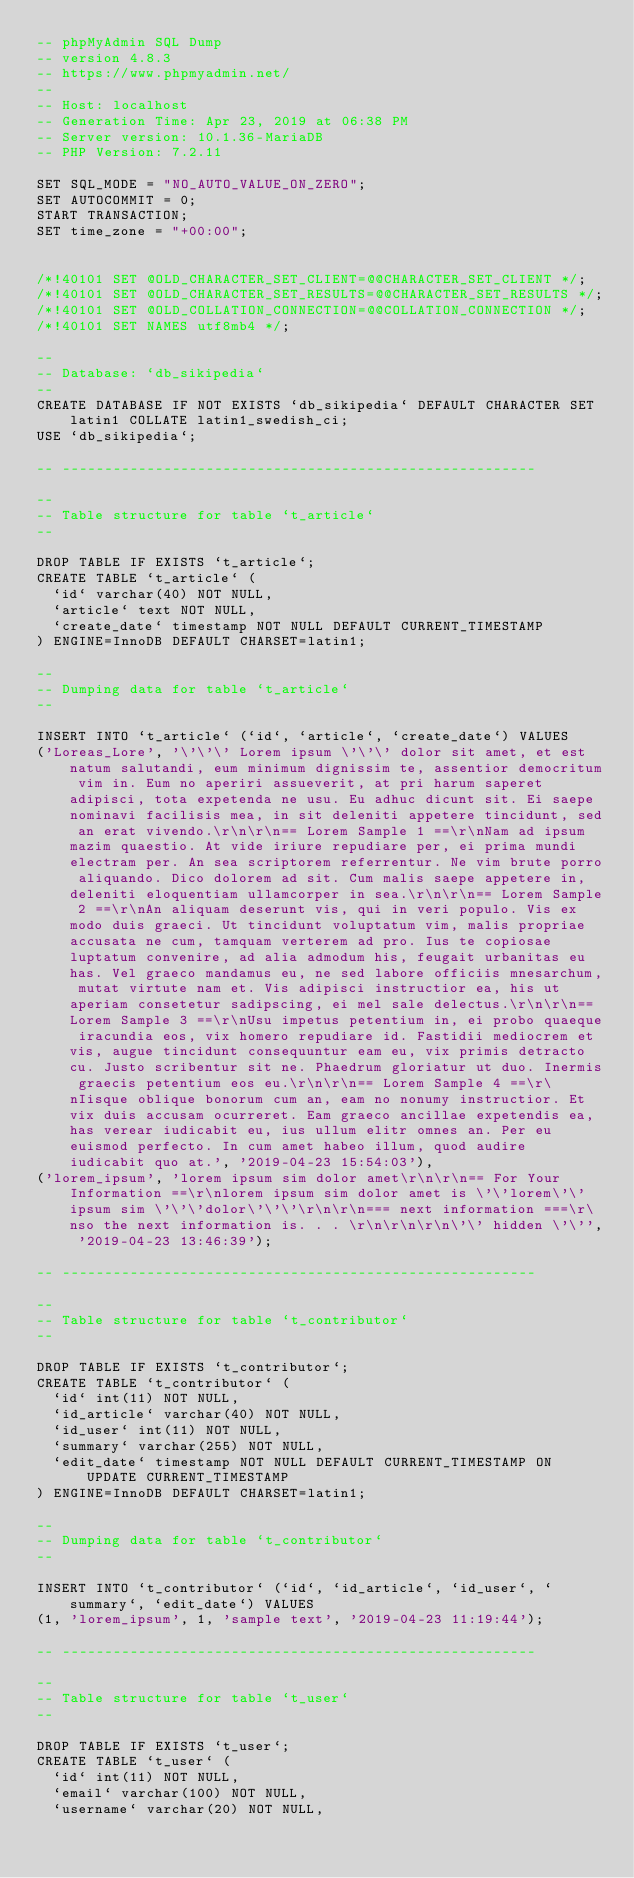<code> <loc_0><loc_0><loc_500><loc_500><_SQL_>-- phpMyAdmin SQL Dump
-- version 4.8.3
-- https://www.phpmyadmin.net/
--
-- Host: localhost
-- Generation Time: Apr 23, 2019 at 06:38 PM
-- Server version: 10.1.36-MariaDB
-- PHP Version: 7.2.11

SET SQL_MODE = "NO_AUTO_VALUE_ON_ZERO";
SET AUTOCOMMIT = 0;
START TRANSACTION;
SET time_zone = "+00:00";


/*!40101 SET @OLD_CHARACTER_SET_CLIENT=@@CHARACTER_SET_CLIENT */;
/*!40101 SET @OLD_CHARACTER_SET_RESULTS=@@CHARACTER_SET_RESULTS */;
/*!40101 SET @OLD_COLLATION_CONNECTION=@@COLLATION_CONNECTION */;
/*!40101 SET NAMES utf8mb4 */;

--
-- Database: `db_sikipedia`
--
CREATE DATABASE IF NOT EXISTS `db_sikipedia` DEFAULT CHARACTER SET latin1 COLLATE latin1_swedish_ci;
USE `db_sikipedia`;

-- --------------------------------------------------------

--
-- Table structure for table `t_article`
--

DROP TABLE IF EXISTS `t_article`;
CREATE TABLE `t_article` (
  `id` varchar(40) NOT NULL,
  `article` text NOT NULL,
  `create_date` timestamp NOT NULL DEFAULT CURRENT_TIMESTAMP
) ENGINE=InnoDB DEFAULT CHARSET=latin1;

--
-- Dumping data for table `t_article`
--

INSERT INTO `t_article` (`id`, `article`, `create_date`) VALUES
('Loreas_Lore', '\'\'\' Lorem ipsum \'\'\' dolor sit amet, et est natum salutandi, eum minimum dignissim te, assentior democritum vim in. Eum no aperiri assueverit, at pri harum saperet adipisci, tota expetenda ne usu. Eu adhuc dicunt sit. Ei saepe nominavi facilisis mea, in sit deleniti appetere tincidunt, sed an erat vivendo.\r\n\r\n== Lorem Sample 1 ==\r\nNam ad ipsum mazim quaestio. At vide iriure repudiare per, ei prima mundi electram per. An sea scriptorem referrentur. Ne vim brute porro aliquando. Dico dolorem ad sit. Cum malis saepe appetere in, deleniti eloquentiam ullamcorper in sea.\r\n\r\n== Lorem Sample 2 ==\r\nAn aliquam deserunt vis, qui in veri populo. Vis ex modo duis graeci. Ut tincidunt voluptatum vim, malis propriae accusata ne cum, tamquam verterem ad pro. Ius te copiosae luptatum convenire, ad alia admodum his, feugait urbanitas eu has. Vel graeco mandamus eu, ne sed labore officiis mnesarchum, mutat virtute nam et. Vis adipisci instructior ea, his ut aperiam consetetur sadipscing, ei mel sale delectus.\r\n\r\n== Lorem Sample 3 ==\r\nUsu impetus petentium in, ei probo quaeque iracundia eos, vix homero repudiare id. Fastidii mediocrem et vis, augue tincidunt consequuntur eam eu, vix primis detracto cu. Justo scribentur sit ne. Phaedrum gloriatur ut duo. Inermis graecis petentium eos eu.\r\n\r\n== Lorem Sample 4 ==\r\nIisque oblique bonorum cum an, eam no nonumy instructior. Et vix duis accusam ocurreret. Eam graeco ancillae expetendis ea, has verear iudicabit eu, ius ullum elitr omnes an. Per eu euismod perfecto. In cum amet habeo illum, quod audire iudicabit quo at.', '2019-04-23 15:54:03'),
('lorem_ipsum', 'lorem ipsum sim dolor amet\r\n\r\n== For Your Information ==\r\nlorem ipsum sim dolor amet is \'\'lorem\'\' ipsum sim \'\'\'dolor\'\'\'\r\n\r\n=== next information ===\r\nso the next information is. . . \r\n\r\n\r\n\'\' hidden \'\'', '2019-04-23 13:46:39');

-- --------------------------------------------------------

--
-- Table structure for table `t_contributor`
--

DROP TABLE IF EXISTS `t_contributor`;
CREATE TABLE `t_contributor` (
  `id` int(11) NOT NULL,
  `id_article` varchar(40) NOT NULL,
  `id_user` int(11) NOT NULL,
  `summary` varchar(255) NOT NULL,
  `edit_date` timestamp NOT NULL DEFAULT CURRENT_TIMESTAMP ON UPDATE CURRENT_TIMESTAMP
) ENGINE=InnoDB DEFAULT CHARSET=latin1;

--
-- Dumping data for table `t_contributor`
--

INSERT INTO `t_contributor` (`id`, `id_article`, `id_user`, `summary`, `edit_date`) VALUES
(1, 'lorem_ipsum', 1, 'sample text', '2019-04-23 11:19:44');

-- --------------------------------------------------------

--
-- Table structure for table `t_user`
--

DROP TABLE IF EXISTS `t_user`;
CREATE TABLE `t_user` (
  `id` int(11) NOT NULL,
  `email` varchar(100) NOT NULL,
  `username` varchar(20) NOT NULL,</code> 